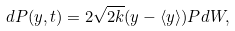Convert formula to latex. <formula><loc_0><loc_0><loc_500><loc_500>d P ( y , t ) = 2 \sqrt { 2 k } ( y - \langle y \rangle ) P d W ,</formula> 